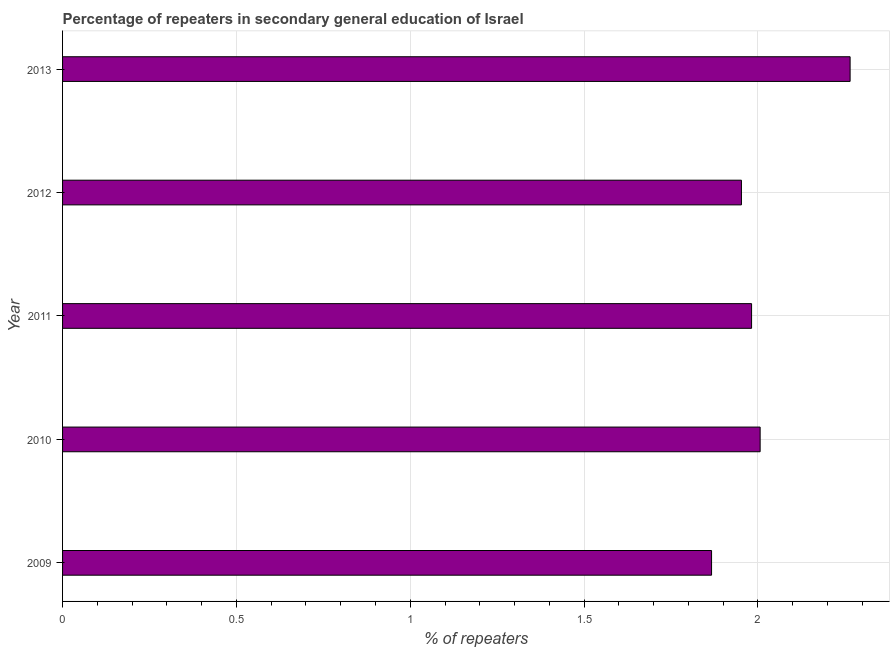Does the graph contain any zero values?
Ensure brevity in your answer.  No. What is the title of the graph?
Offer a terse response. Percentage of repeaters in secondary general education of Israel. What is the label or title of the X-axis?
Make the answer very short. % of repeaters. What is the label or title of the Y-axis?
Offer a very short reply. Year. What is the percentage of repeaters in 2013?
Offer a very short reply. 2.27. Across all years, what is the maximum percentage of repeaters?
Offer a terse response. 2.27. Across all years, what is the minimum percentage of repeaters?
Your answer should be very brief. 1.87. In which year was the percentage of repeaters maximum?
Your answer should be compact. 2013. What is the sum of the percentage of repeaters?
Offer a very short reply. 10.07. What is the difference between the percentage of repeaters in 2009 and 2011?
Ensure brevity in your answer.  -0.12. What is the average percentage of repeaters per year?
Your response must be concise. 2.02. What is the median percentage of repeaters?
Offer a terse response. 1.98. In how many years, is the percentage of repeaters greater than 1.2 %?
Offer a very short reply. 5. Do a majority of the years between 2009 and 2012 (inclusive) have percentage of repeaters greater than 0.9 %?
Your answer should be very brief. Yes. What is the ratio of the percentage of repeaters in 2009 to that in 2012?
Your answer should be very brief. 0.96. Is the percentage of repeaters in 2009 less than that in 2011?
Your answer should be compact. Yes. Is the difference between the percentage of repeaters in 2011 and 2012 greater than the difference between any two years?
Make the answer very short. No. What is the difference between the highest and the second highest percentage of repeaters?
Provide a short and direct response. 0.26. Is the sum of the percentage of repeaters in 2009 and 2011 greater than the maximum percentage of repeaters across all years?
Make the answer very short. Yes. In how many years, is the percentage of repeaters greater than the average percentage of repeaters taken over all years?
Keep it short and to the point. 1. How many years are there in the graph?
Your answer should be very brief. 5. What is the difference between two consecutive major ticks on the X-axis?
Ensure brevity in your answer.  0.5. What is the % of repeaters of 2009?
Your answer should be very brief. 1.87. What is the % of repeaters in 2010?
Offer a terse response. 2.01. What is the % of repeaters in 2011?
Provide a short and direct response. 1.98. What is the % of repeaters of 2012?
Your response must be concise. 1.95. What is the % of repeaters in 2013?
Keep it short and to the point. 2.27. What is the difference between the % of repeaters in 2009 and 2010?
Provide a short and direct response. -0.14. What is the difference between the % of repeaters in 2009 and 2011?
Offer a very short reply. -0.12. What is the difference between the % of repeaters in 2009 and 2012?
Offer a very short reply. -0.09. What is the difference between the % of repeaters in 2009 and 2013?
Your response must be concise. -0.4. What is the difference between the % of repeaters in 2010 and 2011?
Keep it short and to the point. 0.02. What is the difference between the % of repeaters in 2010 and 2012?
Your answer should be compact. 0.05. What is the difference between the % of repeaters in 2010 and 2013?
Your answer should be compact. -0.26. What is the difference between the % of repeaters in 2011 and 2012?
Offer a very short reply. 0.03. What is the difference between the % of repeaters in 2011 and 2013?
Provide a short and direct response. -0.28. What is the difference between the % of repeaters in 2012 and 2013?
Offer a terse response. -0.31. What is the ratio of the % of repeaters in 2009 to that in 2010?
Offer a very short reply. 0.93. What is the ratio of the % of repeaters in 2009 to that in 2011?
Your response must be concise. 0.94. What is the ratio of the % of repeaters in 2009 to that in 2012?
Keep it short and to the point. 0.96. What is the ratio of the % of repeaters in 2009 to that in 2013?
Keep it short and to the point. 0.82. What is the ratio of the % of repeaters in 2010 to that in 2012?
Ensure brevity in your answer.  1.03. What is the ratio of the % of repeaters in 2010 to that in 2013?
Your answer should be very brief. 0.89. What is the ratio of the % of repeaters in 2011 to that in 2013?
Make the answer very short. 0.88. What is the ratio of the % of repeaters in 2012 to that in 2013?
Your response must be concise. 0.86. 